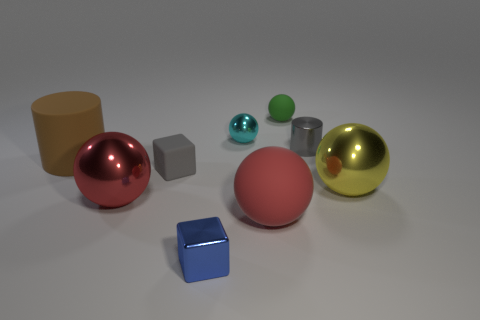What is the color of the tiny shiny cube?
Your answer should be compact. Blue. Are there any metallic balls of the same color as the rubber cube?
Offer a very short reply. No. There is a cylinder that is left of the gray cylinder; is it the same color as the small matte block?
Provide a short and direct response. No. How many things are metallic objects that are in front of the big brown matte cylinder or big balls?
Give a very brief answer. 4. Are there any blue metal things behind the small blue shiny cube?
Make the answer very short. No. There is a object that is the same color as the metallic cylinder; what material is it?
Your answer should be very brief. Rubber. Do the gray thing that is behind the large brown cylinder and the tiny cyan sphere have the same material?
Give a very brief answer. Yes. Is there a large brown matte thing that is on the right side of the metal ball behind the big rubber thing left of the tiny gray matte block?
Your answer should be very brief. No. What number of balls are either tiny rubber things or yellow shiny objects?
Provide a succinct answer. 2. What is the material of the cylinder left of the gray matte block?
Give a very brief answer. Rubber. 